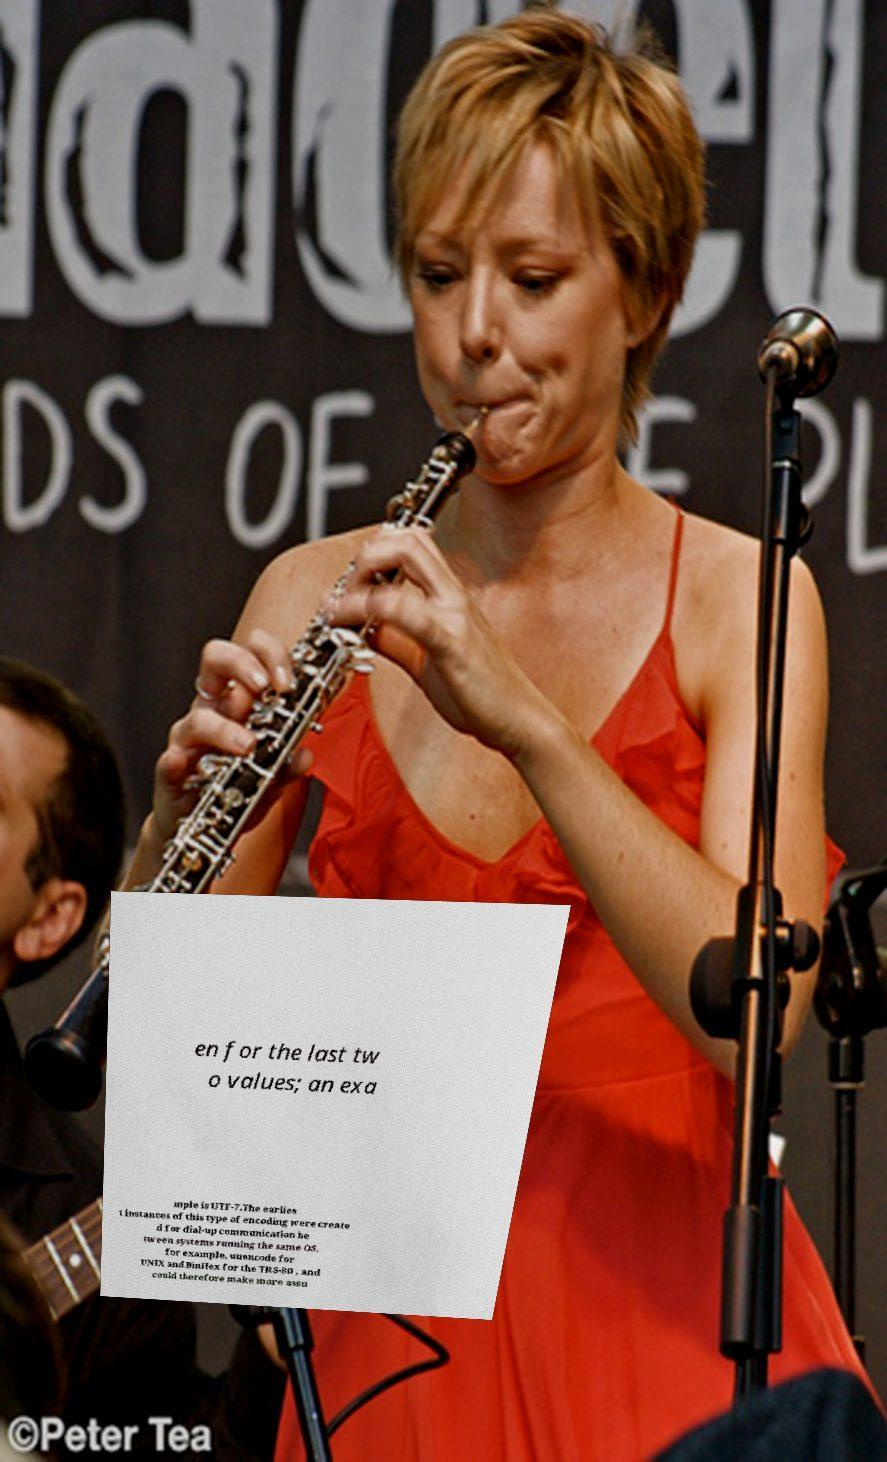Could you extract and type out the text from this image? en for the last tw o values; an exa mple is UTF-7.The earlies t instances of this type of encoding were create d for dial-up communication be tween systems running the same OS, for example, uuencode for UNIX and BinHex for the TRS-80 , and could therefore make more assu 